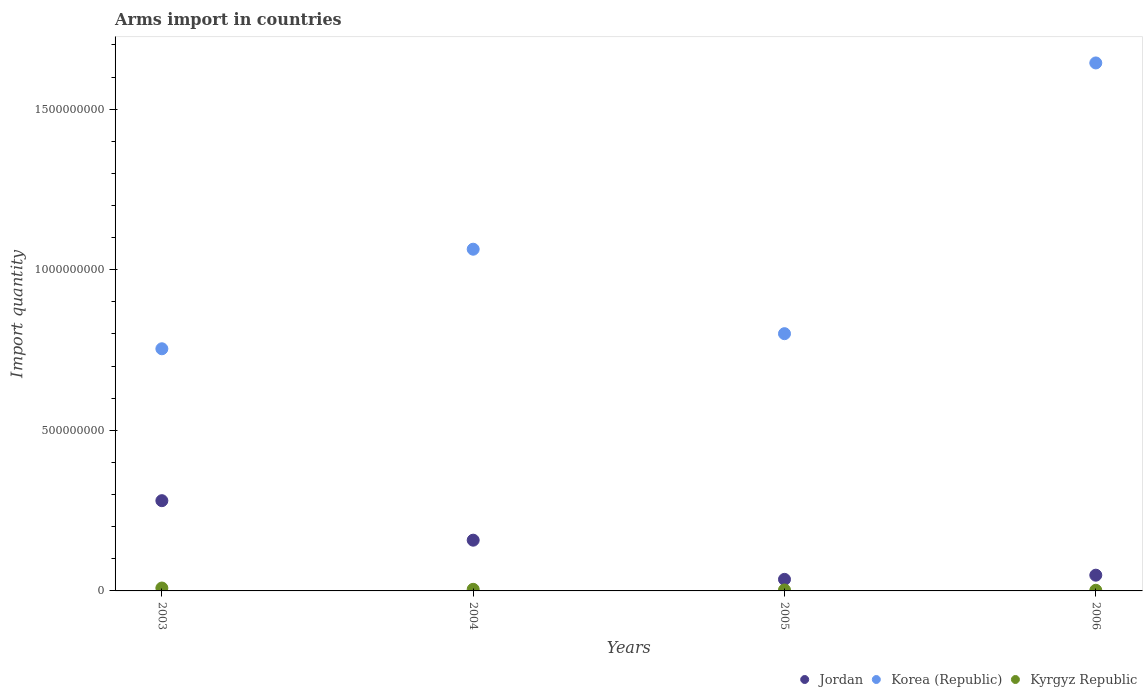How many different coloured dotlines are there?
Your response must be concise. 3. Is the number of dotlines equal to the number of legend labels?
Offer a terse response. Yes. What is the total arms import in Korea (Republic) in 2004?
Provide a short and direct response. 1.06e+09. Across all years, what is the maximum total arms import in Korea (Republic)?
Your answer should be compact. 1.64e+09. Across all years, what is the minimum total arms import in Kyrgyz Republic?
Provide a succinct answer. 2.00e+06. In which year was the total arms import in Jordan minimum?
Offer a very short reply. 2005. What is the total total arms import in Korea (Republic) in the graph?
Your answer should be compact. 4.26e+09. What is the difference between the total arms import in Jordan in 2003 and that in 2006?
Make the answer very short. 2.32e+08. What is the difference between the total arms import in Korea (Republic) in 2006 and the total arms import in Jordan in 2004?
Offer a terse response. 1.49e+09. What is the average total arms import in Kyrgyz Republic per year?
Offer a terse response. 4.75e+06. In the year 2005, what is the difference between the total arms import in Korea (Republic) and total arms import in Kyrgyz Republic?
Your answer should be very brief. 7.98e+08. In how many years, is the total arms import in Korea (Republic) greater than 500000000?
Provide a succinct answer. 4. What is the ratio of the total arms import in Kyrgyz Republic in 2004 to that in 2005?
Make the answer very short. 1.67. Is the total arms import in Jordan in 2004 less than that in 2006?
Your answer should be compact. No. What is the difference between the highest and the second highest total arms import in Korea (Republic)?
Your response must be concise. 5.80e+08. What is the difference between the highest and the lowest total arms import in Korea (Republic)?
Offer a terse response. 8.90e+08. Is the sum of the total arms import in Jordan in 2005 and 2006 greater than the maximum total arms import in Kyrgyz Republic across all years?
Give a very brief answer. Yes. Is it the case that in every year, the sum of the total arms import in Korea (Republic) and total arms import in Jordan  is greater than the total arms import in Kyrgyz Republic?
Ensure brevity in your answer.  Yes. Does the total arms import in Jordan monotonically increase over the years?
Your response must be concise. No. Is the total arms import in Korea (Republic) strictly greater than the total arms import in Kyrgyz Republic over the years?
Your answer should be compact. Yes. Are the values on the major ticks of Y-axis written in scientific E-notation?
Your response must be concise. No. How are the legend labels stacked?
Ensure brevity in your answer.  Horizontal. What is the title of the graph?
Make the answer very short. Arms import in countries. What is the label or title of the X-axis?
Provide a short and direct response. Years. What is the label or title of the Y-axis?
Offer a terse response. Import quantity. What is the Import quantity in Jordan in 2003?
Provide a short and direct response. 2.81e+08. What is the Import quantity in Korea (Republic) in 2003?
Your answer should be compact. 7.54e+08. What is the Import quantity of Kyrgyz Republic in 2003?
Provide a succinct answer. 9.00e+06. What is the Import quantity in Jordan in 2004?
Give a very brief answer. 1.58e+08. What is the Import quantity in Korea (Republic) in 2004?
Your answer should be very brief. 1.06e+09. What is the Import quantity in Kyrgyz Republic in 2004?
Keep it short and to the point. 5.00e+06. What is the Import quantity of Jordan in 2005?
Your response must be concise. 3.60e+07. What is the Import quantity in Korea (Republic) in 2005?
Keep it short and to the point. 8.01e+08. What is the Import quantity in Kyrgyz Republic in 2005?
Ensure brevity in your answer.  3.00e+06. What is the Import quantity in Jordan in 2006?
Offer a terse response. 4.90e+07. What is the Import quantity of Korea (Republic) in 2006?
Offer a terse response. 1.64e+09. Across all years, what is the maximum Import quantity of Jordan?
Provide a short and direct response. 2.81e+08. Across all years, what is the maximum Import quantity of Korea (Republic)?
Your response must be concise. 1.64e+09. Across all years, what is the maximum Import quantity in Kyrgyz Republic?
Your answer should be compact. 9.00e+06. Across all years, what is the minimum Import quantity in Jordan?
Offer a very short reply. 3.60e+07. Across all years, what is the minimum Import quantity in Korea (Republic)?
Give a very brief answer. 7.54e+08. What is the total Import quantity in Jordan in the graph?
Provide a short and direct response. 5.24e+08. What is the total Import quantity in Korea (Republic) in the graph?
Keep it short and to the point. 4.26e+09. What is the total Import quantity of Kyrgyz Republic in the graph?
Give a very brief answer. 1.90e+07. What is the difference between the Import quantity in Jordan in 2003 and that in 2004?
Provide a short and direct response. 1.23e+08. What is the difference between the Import quantity in Korea (Republic) in 2003 and that in 2004?
Give a very brief answer. -3.10e+08. What is the difference between the Import quantity of Kyrgyz Republic in 2003 and that in 2004?
Make the answer very short. 4.00e+06. What is the difference between the Import quantity in Jordan in 2003 and that in 2005?
Make the answer very short. 2.45e+08. What is the difference between the Import quantity of Korea (Republic) in 2003 and that in 2005?
Give a very brief answer. -4.70e+07. What is the difference between the Import quantity of Jordan in 2003 and that in 2006?
Your answer should be very brief. 2.32e+08. What is the difference between the Import quantity in Korea (Republic) in 2003 and that in 2006?
Your answer should be compact. -8.90e+08. What is the difference between the Import quantity of Kyrgyz Republic in 2003 and that in 2006?
Ensure brevity in your answer.  7.00e+06. What is the difference between the Import quantity of Jordan in 2004 and that in 2005?
Offer a very short reply. 1.22e+08. What is the difference between the Import quantity of Korea (Republic) in 2004 and that in 2005?
Your answer should be very brief. 2.63e+08. What is the difference between the Import quantity in Jordan in 2004 and that in 2006?
Your answer should be compact. 1.09e+08. What is the difference between the Import quantity of Korea (Republic) in 2004 and that in 2006?
Your answer should be very brief. -5.80e+08. What is the difference between the Import quantity of Jordan in 2005 and that in 2006?
Offer a terse response. -1.30e+07. What is the difference between the Import quantity in Korea (Republic) in 2005 and that in 2006?
Your response must be concise. -8.43e+08. What is the difference between the Import quantity in Jordan in 2003 and the Import quantity in Korea (Republic) in 2004?
Ensure brevity in your answer.  -7.83e+08. What is the difference between the Import quantity of Jordan in 2003 and the Import quantity of Kyrgyz Republic in 2004?
Your answer should be compact. 2.76e+08. What is the difference between the Import quantity of Korea (Republic) in 2003 and the Import quantity of Kyrgyz Republic in 2004?
Provide a succinct answer. 7.49e+08. What is the difference between the Import quantity in Jordan in 2003 and the Import quantity in Korea (Republic) in 2005?
Your response must be concise. -5.20e+08. What is the difference between the Import quantity of Jordan in 2003 and the Import quantity of Kyrgyz Republic in 2005?
Offer a very short reply. 2.78e+08. What is the difference between the Import quantity of Korea (Republic) in 2003 and the Import quantity of Kyrgyz Republic in 2005?
Give a very brief answer. 7.51e+08. What is the difference between the Import quantity of Jordan in 2003 and the Import quantity of Korea (Republic) in 2006?
Make the answer very short. -1.36e+09. What is the difference between the Import quantity of Jordan in 2003 and the Import quantity of Kyrgyz Republic in 2006?
Your answer should be very brief. 2.79e+08. What is the difference between the Import quantity of Korea (Republic) in 2003 and the Import quantity of Kyrgyz Republic in 2006?
Your answer should be compact. 7.52e+08. What is the difference between the Import quantity of Jordan in 2004 and the Import quantity of Korea (Republic) in 2005?
Offer a terse response. -6.43e+08. What is the difference between the Import quantity of Jordan in 2004 and the Import quantity of Kyrgyz Republic in 2005?
Provide a short and direct response. 1.55e+08. What is the difference between the Import quantity in Korea (Republic) in 2004 and the Import quantity in Kyrgyz Republic in 2005?
Offer a very short reply. 1.06e+09. What is the difference between the Import quantity in Jordan in 2004 and the Import quantity in Korea (Republic) in 2006?
Provide a succinct answer. -1.49e+09. What is the difference between the Import quantity in Jordan in 2004 and the Import quantity in Kyrgyz Republic in 2006?
Offer a terse response. 1.56e+08. What is the difference between the Import quantity in Korea (Republic) in 2004 and the Import quantity in Kyrgyz Republic in 2006?
Make the answer very short. 1.06e+09. What is the difference between the Import quantity of Jordan in 2005 and the Import quantity of Korea (Republic) in 2006?
Your answer should be very brief. -1.61e+09. What is the difference between the Import quantity in Jordan in 2005 and the Import quantity in Kyrgyz Republic in 2006?
Offer a very short reply. 3.40e+07. What is the difference between the Import quantity of Korea (Republic) in 2005 and the Import quantity of Kyrgyz Republic in 2006?
Offer a terse response. 7.99e+08. What is the average Import quantity in Jordan per year?
Your answer should be very brief. 1.31e+08. What is the average Import quantity in Korea (Republic) per year?
Your answer should be very brief. 1.07e+09. What is the average Import quantity of Kyrgyz Republic per year?
Your answer should be compact. 4.75e+06. In the year 2003, what is the difference between the Import quantity of Jordan and Import quantity of Korea (Republic)?
Your answer should be compact. -4.73e+08. In the year 2003, what is the difference between the Import quantity in Jordan and Import quantity in Kyrgyz Republic?
Offer a very short reply. 2.72e+08. In the year 2003, what is the difference between the Import quantity in Korea (Republic) and Import quantity in Kyrgyz Republic?
Make the answer very short. 7.45e+08. In the year 2004, what is the difference between the Import quantity in Jordan and Import quantity in Korea (Republic)?
Your answer should be very brief. -9.06e+08. In the year 2004, what is the difference between the Import quantity of Jordan and Import quantity of Kyrgyz Republic?
Make the answer very short. 1.53e+08. In the year 2004, what is the difference between the Import quantity of Korea (Republic) and Import quantity of Kyrgyz Republic?
Provide a short and direct response. 1.06e+09. In the year 2005, what is the difference between the Import quantity in Jordan and Import quantity in Korea (Republic)?
Ensure brevity in your answer.  -7.65e+08. In the year 2005, what is the difference between the Import quantity of Jordan and Import quantity of Kyrgyz Republic?
Keep it short and to the point. 3.30e+07. In the year 2005, what is the difference between the Import quantity in Korea (Republic) and Import quantity in Kyrgyz Republic?
Your answer should be very brief. 7.98e+08. In the year 2006, what is the difference between the Import quantity of Jordan and Import quantity of Korea (Republic)?
Give a very brief answer. -1.60e+09. In the year 2006, what is the difference between the Import quantity in Jordan and Import quantity in Kyrgyz Republic?
Offer a terse response. 4.70e+07. In the year 2006, what is the difference between the Import quantity of Korea (Republic) and Import quantity of Kyrgyz Republic?
Give a very brief answer. 1.64e+09. What is the ratio of the Import quantity of Jordan in 2003 to that in 2004?
Offer a terse response. 1.78. What is the ratio of the Import quantity of Korea (Republic) in 2003 to that in 2004?
Offer a very short reply. 0.71. What is the ratio of the Import quantity in Kyrgyz Republic in 2003 to that in 2004?
Provide a short and direct response. 1.8. What is the ratio of the Import quantity in Jordan in 2003 to that in 2005?
Your answer should be very brief. 7.81. What is the ratio of the Import quantity of Korea (Republic) in 2003 to that in 2005?
Your response must be concise. 0.94. What is the ratio of the Import quantity in Kyrgyz Republic in 2003 to that in 2005?
Your response must be concise. 3. What is the ratio of the Import quantity of Jordan in 2003 to that in 2006?
Give a very brief answer. 5.73. What is the ratio of the Import quantity of Korea (Republic) in 2003 to that in 2006?
Give a very brief answer. 0.46. What is the ratio of the Import quantity of Jordan in 2004 to that in 2005?
Provide a short and direct response. 4.39. What is the ratio of the Import quantity in Korea (Republic) in 2004 to that in 2005?
Your answer should be very brief. 1.33. What is the ratio of the Import quantity of Jordan in 2004 to that in 2006?
Offer a terse response. 3.22. What is the ratio of the Import quantity in Korea (Republic) in 2004 to that in 2006?
Provide a short and direct response. 0.65. What is the ratio of the Import quantity in Kyrgyz Republic in 2004 to that in 2006?
Ensure brevity in your answer.  2.5. What is the ratio of the Import quantity of Jordan in 2005 to that in 2006?
Give a very brief answer. 0.73. What is the ratio of the Import quantity in Korea (Republic) in 2005 to that in 2006?
Your answer should be very brief. 0.49. What is the ratio of the Import quantity of Kyrgyz Republic in 2005 to that in 2006?
Offer a very short reply. 1.5. What is the difference between the highest and the second highest Import quantity of Jordan?
Give a very brief answer. 1.23e+08. What is the difference between the highest and the second highest Import quantity of Korea (Republic)?
Make the answer very short. 5.80e+08. What is the difference between the highest and the second highest Import quantity of Kyrgyz Republic?
Ensure brevity in your answer.  4.00e+06. What is the difference between the highest and the lowest Import quantity in Jordan?
Provide a short and direct response. 2.45e+08. What is the difference between the highest and the lowest Import quantity in Korea (Republic)?
Make the answer very short. 8.90e+08. 